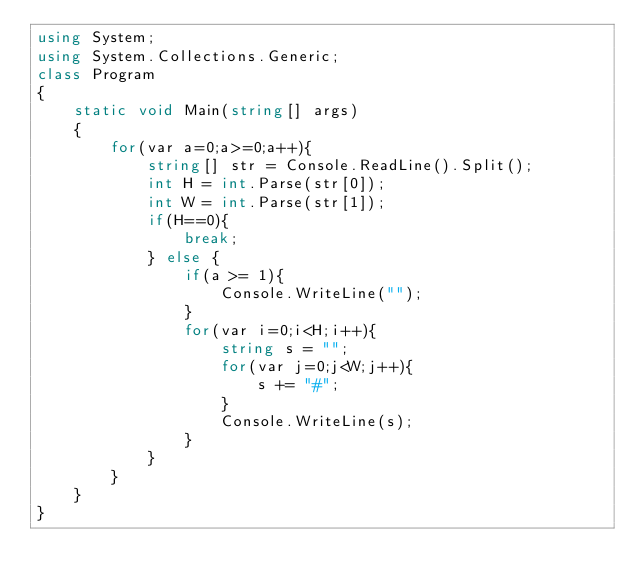Convert code to text. <code><loc_0><loc_0><loc_500><loc_500><_C#_>using System;
using System.Collections.Generic;
class Program
{
	static void Main(string[] args)
	{
		for(var a=0;a>=0;a++){
			string[] str = Console.ReadLine().Split();
			int H = int.Parse(str[0]);
			int W = int.Parse(str[1]);
			if(H==0){
				break;
			} else {
				if(a >= 1){
					Console.WriteLine("");
				}
				for(var i=0;i<H;i++){
					string s = "";
					for(var j=0;j<W;j++){
						s += "#";
					}
					Console.WriteLine(s);
				}
			}
		}
	}
}
</code> 